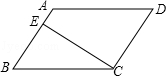Articulate your interpretation of the image. The diagram displays a parallelogram with vertices labeled as A, B, C, and D. The sides AB and CD are parallel, while the sides AD and BC are also parallel. A line CE is drawn perpendicular to line AB, and point E is where the perpendicular line meets AB. 